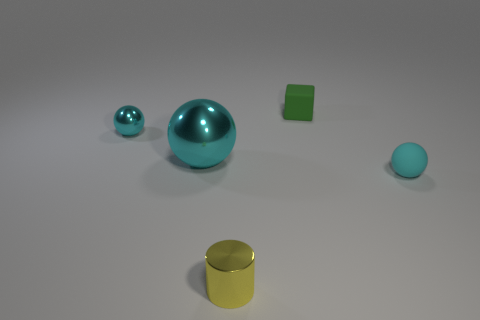Subtract all tiny shiny balls. How many balls are left? 2 Add 1 small green matte objects. How many objects exist? 6 Subtract all large yellow shiny cylinders. Subtract all large cyan objects. How many objects are left? 4 Add 3 rubber cubes. How many rubber cubes are left? 4 Add 1 green rubber cylinders. How many green rubber cylinders exist? 1 Subtract 0 gray cylinders. How many objects are left? 5 Subtract all cylinders. How many objects are left? 4 Subtract all gray cylinders. Subtract all red cubes. How many cylinders are left? 1 